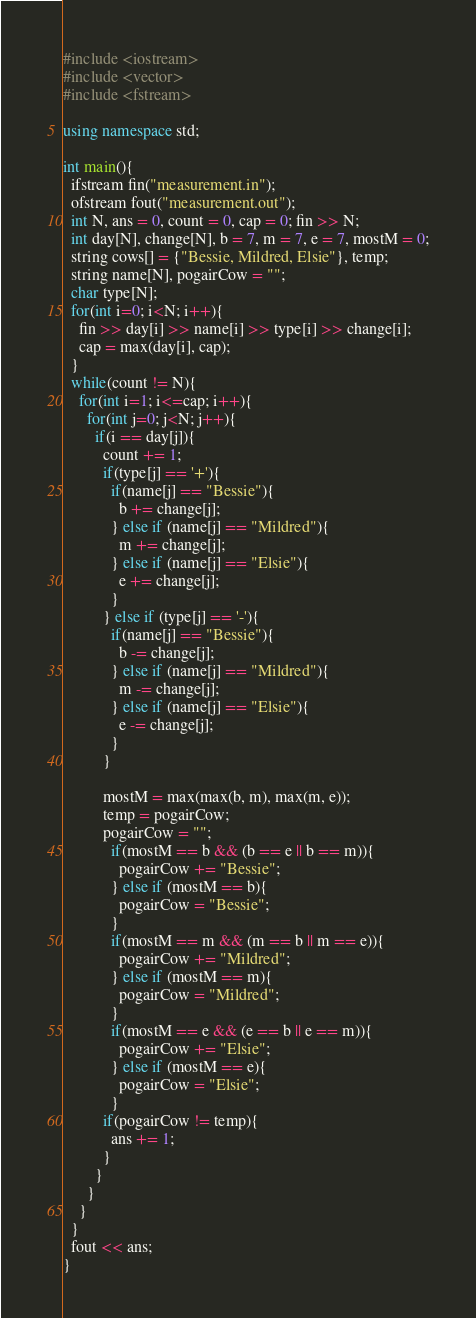<code> <loc_0><loc_0><loc_500><loc_500><_C++_>#include <iostream>
#include <vector>
#include <fstream>

using namespace std;

int main(){
  ifstream fin("measurement.in");
  ofstream fout("measurement.out");
  int N, ans = 0, count = 0, cap = 0; fin >> N;
  int day[N], change[N], b = 7, m = 7, e = 7, mostM = 0;
  string cows[] = {"Bessie, Mildred, Elsie"}, temp;
  string name[N], pogairCow = "";
  char type[N];
  for(int i=0; i<N; i++){
    fin >> day[i] >> name[i] >> type[i] >> change[i];
    cap = max(day[i], cap);
  }
  while(count != N){
    for(int i=1; i<=cap; i++){
      for(int j=0; j<N; j++){
        if(i == day[j]){
          count += 1;
          if(type[j] == '+'){
            if(name[j] == "Bessie"){
              b += change[j];
            } else if (name[j] == "Mildred"){
              m += change[j];
            } else if (name[j] == "Elsie"){
              e += change[j];
            }
          } else if (type[j] == '-'){
            if(name[j] == "Bessie"){
              b -= change[j];
            } else if (name[j] == "Mildred"){
              m -= change[j];
            } else if (name[j] == "Elsie"){
              e -= change[j];
            }
          }

          mostM = max(max(b, m), max(m, e));
          temp = pogairCow;
          pogairCow = "";
            if(mostM == b && (b == e || b == m)){
              pogairCow += "Bessie";
            } else if (mostM == b){
              pogairCow = "Bessie";
            }
            if(mostM == m && (m == b || m == e)){
              pogairCow += "Mildred";
            } else if (mostM == m){
              pogairCow = "Mildred";
            }
            if(mostM == e && (e == b || e == m)){
              pogairCow += "Elsie";
            } else if (mostM == e){
              pogairCow = "Elsie"; 
            }
          if(pogairCow != temp){
            ans += 1;
          }
        }
      }
    }
  }
  fout << ans;
}
</code> 